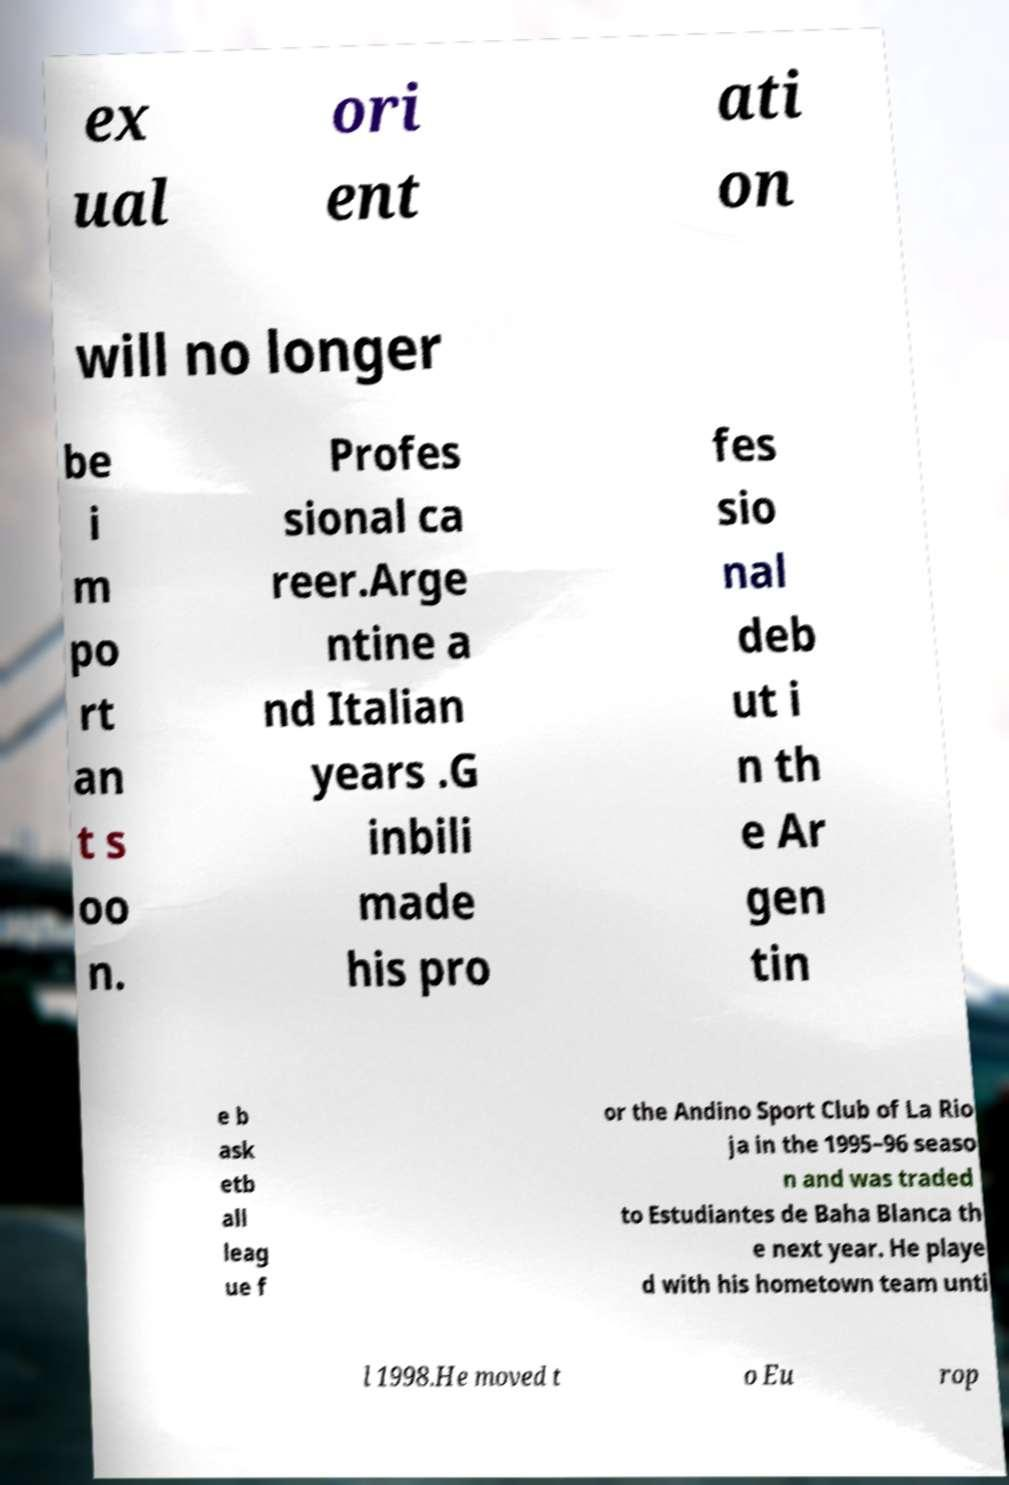What messages or text are displayed in this image? I need them in a readable, typed format. ex ual ori ent ati on will no longer be i m po rt an t s oo n. Profes sional ca reer.Arge ntine a nd Italian years .G inbili made his pro fes sio nal deb ut i n th e Ar gen tin e b ask etb all leag ue f or the Andino Sport Club of La Rio ja in the 1995–96 seaso n and was traded to Estudiantes de Baha Blanca th e next year. He playe d with his hometown team unti l 1998.He moved t o Eu rop 